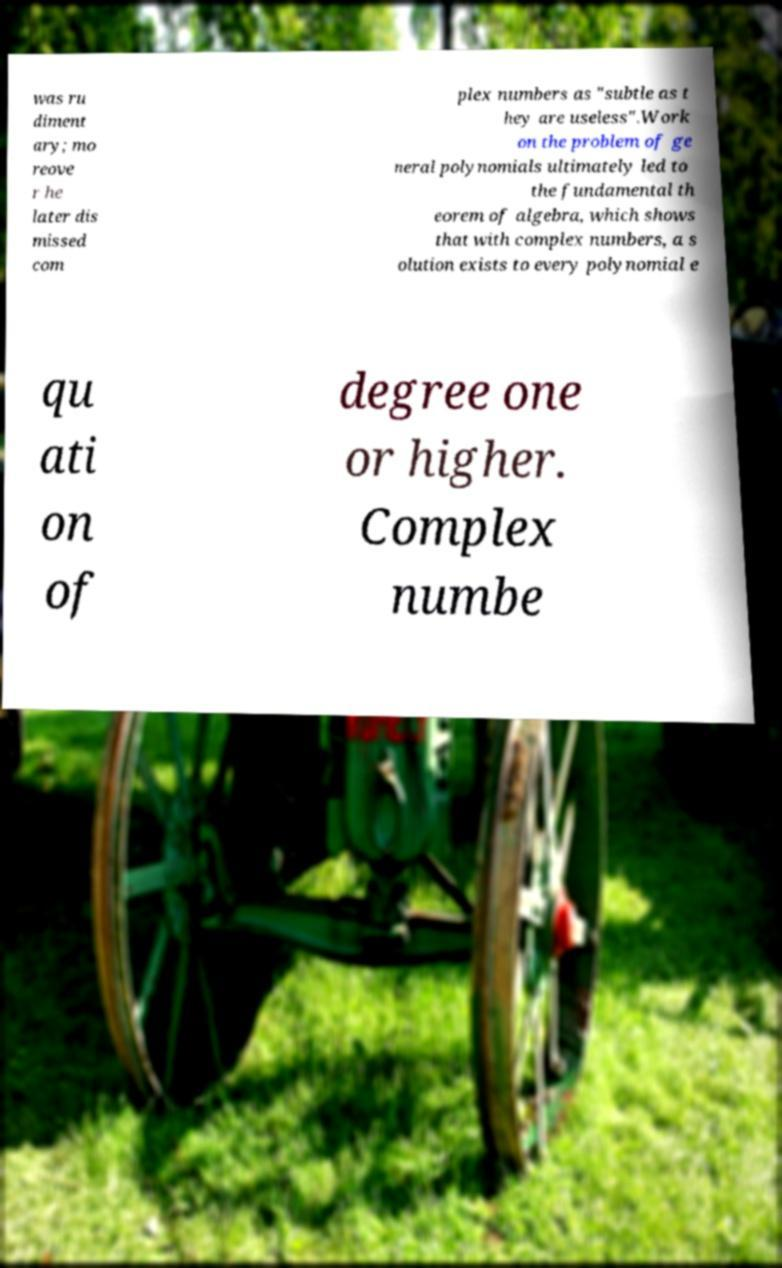For documentation purposes, I need the text within this image transcribed. Could you provide that? was ru diment ary; mo reove r he later dis missed com plex numbers as "subtle as t hey are useless".Work on the problem of ge neral polynomials ultimately led to the fundamental th eorem of algebra, which shows that with complex numbers, a s olution exists to every polynomial e qu ati on of degree one or higher. Complex numbe 